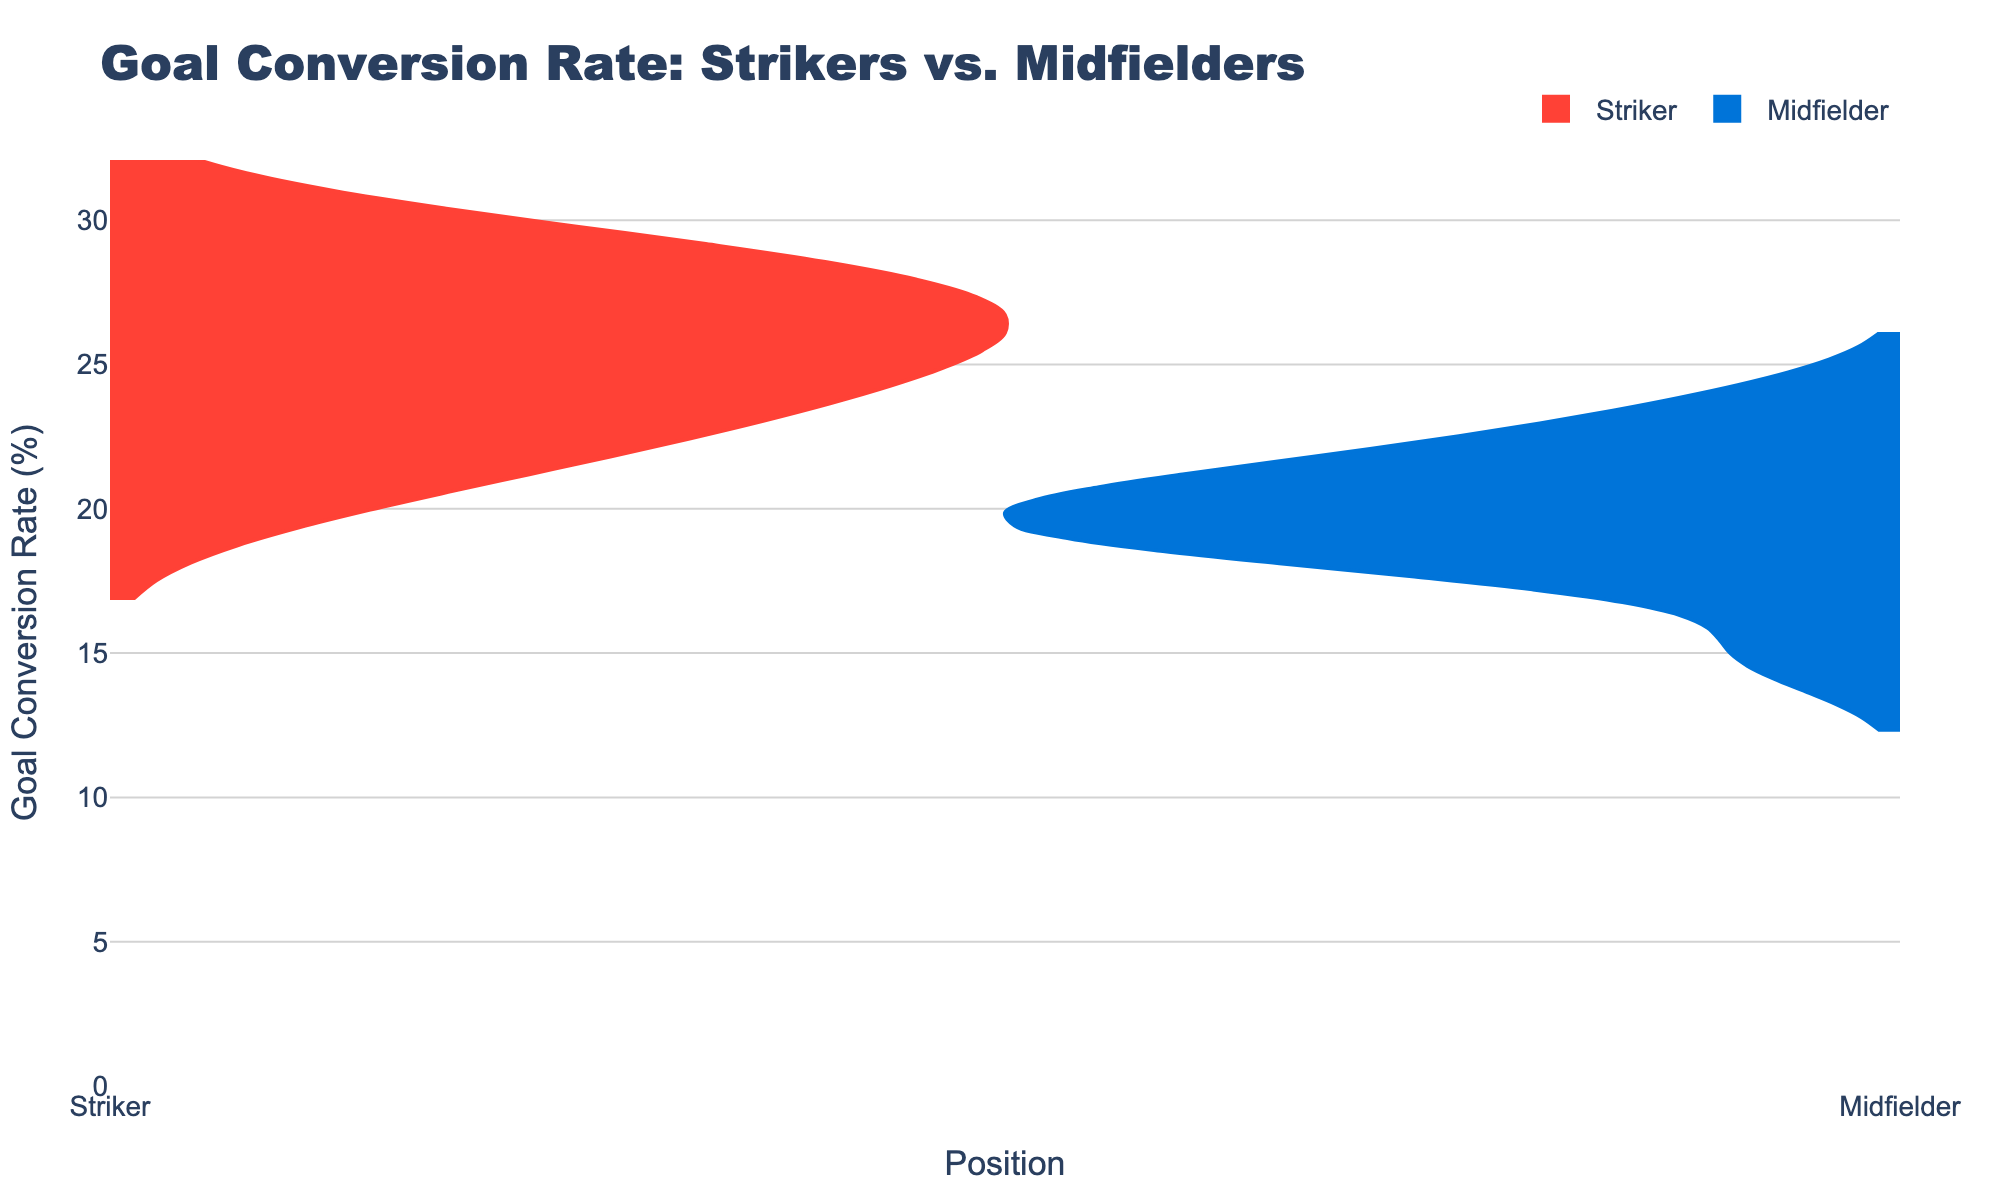what is the title of the figure? The title of the figure is written at the top of the chart. Reading the text, it's clear that the title is "Goal Conversion Rate: Strikers vs. Midfielders".
Answer: Goal Conversion Rate: Strikers vs. Midfielders How many data points are there for midfielders? We need to count the individual data points for midfielders in the figure. There are 10 data points present for midfielders.
Answer: 10 Which position has a higher median goal conversion rate? To determine this, we need to visually inspect the violin plots and estimate where the medians, or middle values, lie. The median of the strikers appears to be higher than that of the midfielders.
Answer: Strikers What is the range of goal conversion rates for strikers? The range is calculated by subtracting the minimum conversion rate from the maximum. The lowest is Romelu Lukaku at 20.59%, and the highest is Erling Haaland at 29.17%. Therefore, the range is 29.17% - 20.59% = 8.58%.
Answer: 8.58% Who has the highest goal conversion rate among midfielders? Looking at the hover text for midfielders, the highest goal conversion rate is by Phil Foden, which is 23.40%.
Answer: Phil Foden Are there more data points for strikers or midfielders? By counting the number of violins for each position, we see there are 10 strikers and 10 midfielders. Hence, the number of data points is the same.
Answer: Same What is the average goal conversion rate for midfielders? To find this, we sum the goal conversion rates for all midfielders and divide by the number of midfielders. Adding (20.00 + 18.75 + 21.62 + 20.00 + 18.75 + 20.00 + 23.40 + 15.00 + 18.18 + 21.43) / 10 = 19.51%.
Answer: 19.51% Which player has the highest goal conversion rate in the entire dataset? We need to look at both groups to find the maximum value. Erling Haaland has the highest goal conversion rate at 29.17%.
Answer: Erling Haaland What is the difference in the average goal conversion rate between strikers and midfielders? First, calculate the average for strikers: sum (28.57 + 26.92 + 29.17 + 27.69 + 26.23 + 25.00 + 25.00 + 22.73 + 20.59 + 23.08) / 10 = 25.298%. Then subtract the average for midfielders from this: 25.298 - 19.51 = 5.788%.
Answer: 5.788% 